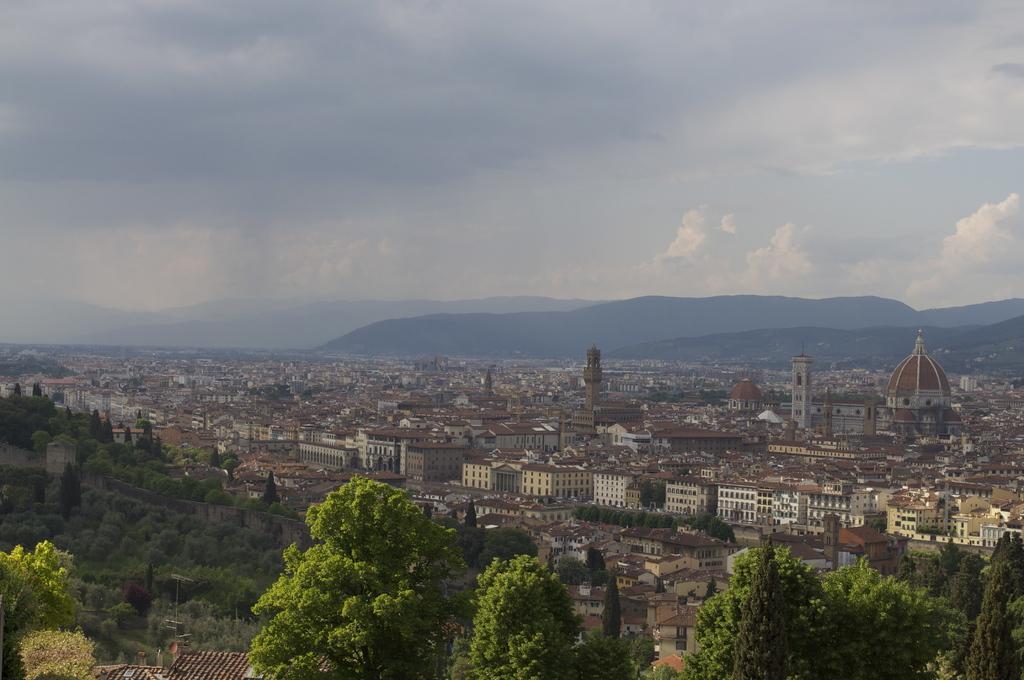Describe this image in one or two sentences. In the picture we can see an Ariel view of the city with trees, plants, houses, buildings, palaces and in the background we can see a hill and a sky with clouds. 